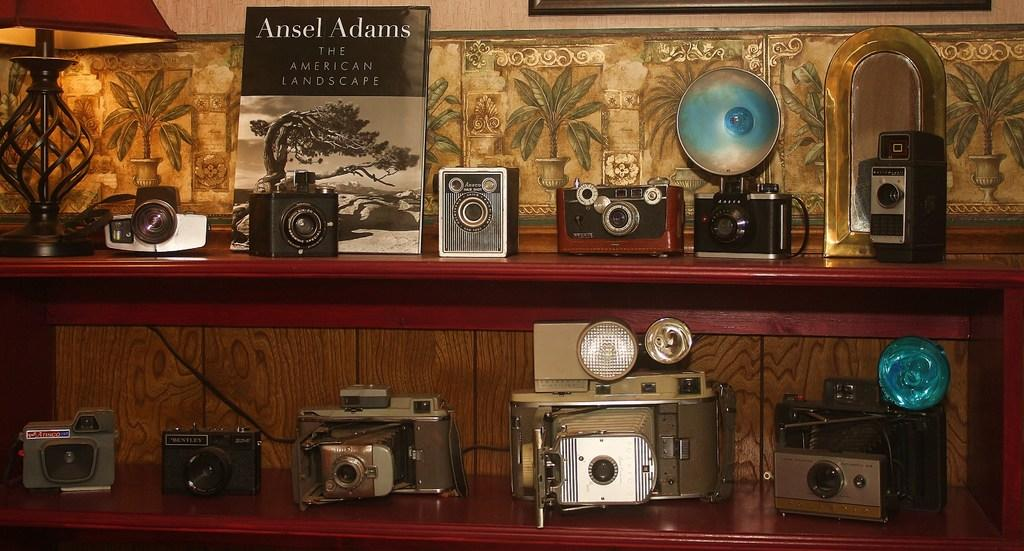What type of objects can be seen on shelves in the image? There are electronic devices on shelves in the image. Where is the lamp located in the image? The lamp is on the left side of the image. What is present on a shelf in the image? There is a board on a shelf in the image. What type of flag is being exchanged between the electronic devices in the image? There is no flag or exchange between electronic devices present in the image. What holiday is being celebrated in the image? There is no indication of a holiday being celebrated in the image. 